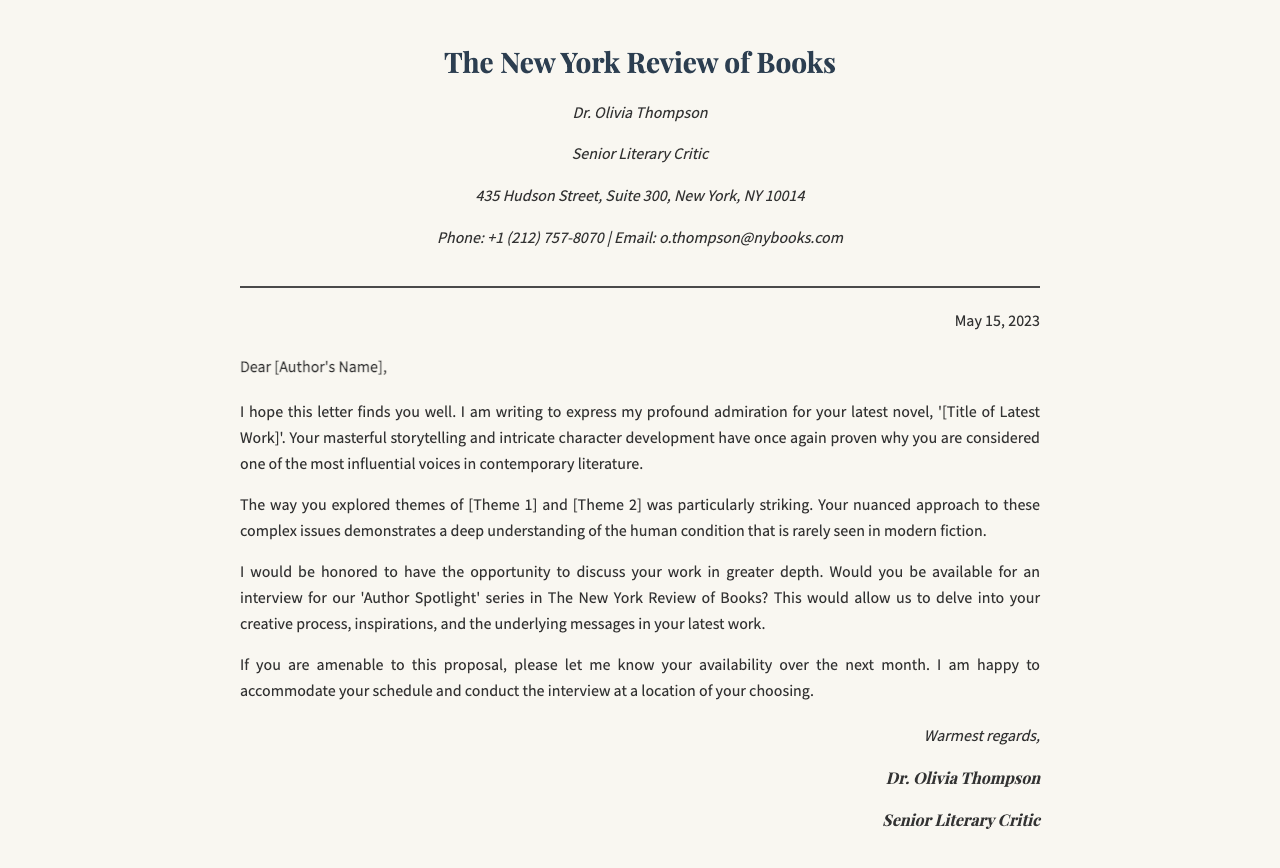What is the date of the letter? The date is clearly stated at the top right of the document.
Answer: May 15, 2023 Who is the sender of the letter? The sender’s name and title are provided in the header of the document.
Answer: Dr. Olivia Thompson What is the title of the author's latest work? The title of the work is mentioned in the content of the letter.
Answer: [Title of Latest Work] What themes were praised in the letter? The letter specifically mentions themes explored in the author's work.
Answer: [Theme 1] and [Theme 2] What series is the interview for? The purpose of the letter indicates the series the interview will be featured in.
Answer: 'Author Spotlight' How can the author contact the sender? Contact details are provided in the sender's information section.
Answer: Email: o.thompson@nybooks.com What is the main purpose of the letter? The content outlines the primary reason for writing the letter.
Answer: Request an interview What organization is the sender associated with? The header provides the name of the organization.
Answer: The New York Review of Books What role does Dr. Olivia Thompson hold? The title is mentioned right below her name in the header.
Answer: Senior Literary Critic 